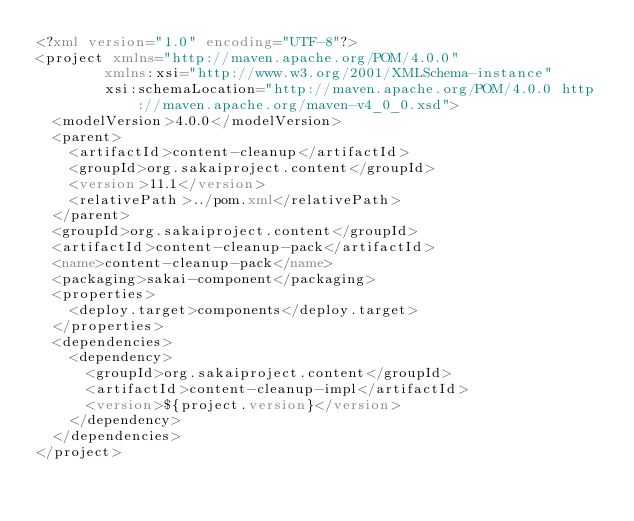<code> <loc_0><loc_0><loc_500><loc_500><_XML_><?xml version="1.0" encoding="UTF-8"?>
<project xmlns="http://maven.apache.org/POM/4.0.0"
        xmlns:xsi="http://www.w3.org/2001/XMLSchema-instance"
        xsi:schemaLocation="http://maven.apache.org/POM/4.0.0 http://maven.apache.org/maven-v4_0_0.xsd">
  <modelVersion>4.0.0</modelVersion>
  <parent>
    <artifactId>content-cleanup</artifactId>
    <groupId>org.sakaiproject.content</groupId>
    <version>11.1</version>
    <relativePath>../pom.xml</relativePath>
  </parent>
  <groupId>org.sakaiproject.content</groupId>
  <artifactId>content-cleanup-pack</artifactId>
  <name>content-cleanup-pack</name>
  <packaging>sakai-component</packaging>
  <properties>
	  <deploy.target>components</deploy.target>
  </properties>
  <dependencies>
	  <dependency>
		  <groupId>org.sakaiproject.content</groupId>
		  <artifactId>content-cleanup-impl</artifactId>
		  <version>${project.version}</version>
	  </dependency>
  </dependencies>
</project>
</code> 